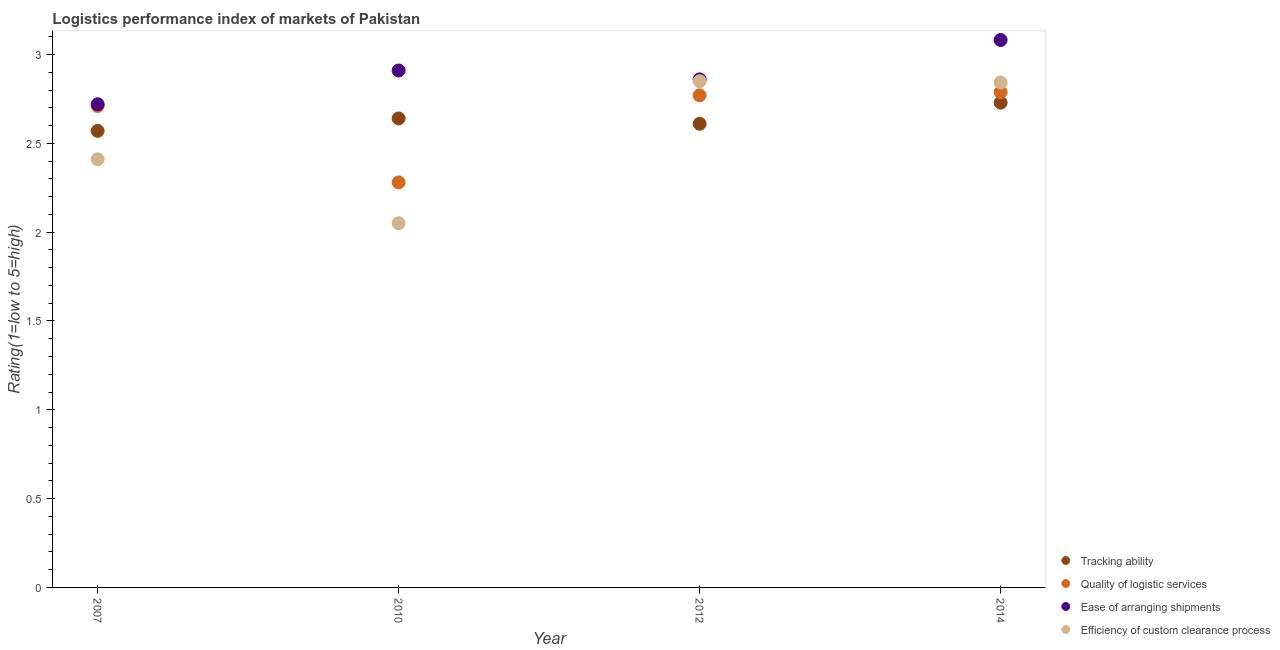How many different coloured dotlines are there?
Keep it short and to the point. 4. Is the number of dotlines equal to the number of legend labels?
Make the answer very short. Yes. What is the lpi rating of efficiency of custom clearance process in 2010?
Your answer should be very brief. 2.05. Across all years, what is the maximum lpi rating of quality of logistic services?
Your answer should be compact. 2.79. Across all years, what is the minimum lpi rating of efficiency of custom clearance process?
Your answer should be very brief. 2.05. In which year was the lpi rating of quality of logistic services minimum?
Offer a terse response. 2010. What is the total lpi rating of tracking ability in the graph?
Ensure brevity in your answer.  10.55. What is the difference between the lpi rating of efficiency of custom clearance process in 2010 and that in 2012?
Give a very brief answer. -0.8. What is the difference between the lpi rating of efficiency of custom clearance process in 2007 and the lpi rating of tracking ability in 2012?
Provide a short and direct response. -0.2. What is the average lpi rating of quality of logistic services per year?
Ensure brevity in your answer.  2.64. In the year 2012, what is the difference between the lpi rating of quality of logistic services and lpi rating of tracking ability?
Give a very brief answer. 0.16. What is the ratio of the lpi rating of quality of logistic services in 2007 to that in 2014?
Provide a short and direct response. 0.97. Is the difference between the lpi rating of tracking ability in 2007 and 2014 greater than the difference between the lpi rating of quality of logistic services in 2007 and 2014?
Give a very brief answer. No. What is the difference between the highest and the second highest lpi rating of ease of arranging shipments?
Offer a very short reply. 0.17. What is the difference between the highest and the lowest lpi rating of quality of logistic services?
Provide a succinct answer. 0.51. Is the sum of the lpi rating of ease of arranging shipments in 2010 and 2014 greater than the maximum lpi rating of tracking ability across all years?
Provide a succinct answer. Yes. Is the lpi rating of efficiency of custom clearance process strictly less than the lpi rating of quality of logistic services over the years?
Offer a very short reply. No. How many dotlines are there?
Provide a short and direct response. 4. How many years are there in the graph?
Offer a terse response. 4. What is the difference between two consecutive major ticks on the Y-axis?
Your answer should be compact. 0.5. Are the values on the major ticks of Y-axis written in scientific E-notation?
Keep it short and to the point. No. Does the graph contain any zero values?
Offer a very short reply. No. Where does the legend appear in the graph?
Give a very brief answer. Bottom right. How many legend labels are there?
Your response must be concise. 4. How are the legend labels stacked?
Your response must be concise. Vertical. What is the title of the graph?
Your answer should be very brief. Logistics performance index of markets of Pakistan. What is the label or title of the Y-axis?
Your response must be concise. Rating(1=low to 5=high). What is the Rating(1=low to 5=high) of Tracking ability in 2007?
Provide a short and direct response. 2.57. What is the Rating(1=low to 5=high) in Quality of logistic services in 2007?
Keep it short and to the point. 2.71. What is the Rating(1=low to 5=high) in Ease of arranging shipments in 2007?
Offer a very short reply. 2.72. What is the Rating(1=low to 5=high) of Efficiency of custom clearance process in 2007?
Your answer should be compact. 2.41. What is the Rating(1=low to 5=high) of Tracking ability in 2010?
Your answer should be compact. 2.64. What is the Rating(1=low to 5=high) in Quality of logistic services in 2010?
Your response must be concise. 2.28. What is the Rating(1=low to 5=high) of Ease of arranging shipments in 2010?
Your response must be concise. 2.91. What is the Rating(1=low to 5=high) in Efficiency of custom clearance process in 2010?
Make the answer very short. 2.05. What is the Rating(1=low to 5=high) of Tracking ability in 2012?
Your answer should be compact. 2.61. What is the Rating(1=low to 5=high) of Quality of logistic services in 2012?
Provide a short and direct response. 2.77. What is the Rating(1=low to 5=high) of Ease of arranging shipments in 2012?
Your answer should be very brief. 2.86. What is the Rating(1=low to 5=high) in Efficiency of custom clearance process in 2012?
Offer a very short reply. 2.85. What is the Rating(1=low to 5=high) in Tracking ability in 2014?
Your answer should be very brief. 2.73. What is the Rating(1=low to 5=high) of Quality of logistic services in 2014?
Your answer should be compact. 2.79. What is the Rating(1=low to 5=high) in Ease of arranging shipments in 2014?
Provide a short and direct response. 3.08. What is the Rating(1=low to 5=high) in Efficiency of custom clearance process in 2014?
Offer a very short reply. 2.84. Across all years, what is the maximum Rating(1=low to 5=high) of Tracking ability?
Offer a terse response. 2.73. Across all years, what is the maximum Rating(1=low to 5=high) of Quality of logistic services?
Provide a short and direct response. 2.79. Across all years, what is the maximum Rating(1=low to 5=high) in Ease of arranging shipments?
Provide a succinct answer. 3.08. Across all years, what is the maximum Rating(1=low to 5=high) in Efficiency of custom clearance process?
Your answer should be very brief. 2.85. Across all years, what is the minimum Rating(1=low to 5=high) in Tracking ability?
Offer a very short reply. 2.57. Across all years, what is the minimum Rating(1=low to 5=high) of Quality of logistic services?
Your answer should be compact. 2.28. Across all years, what is the minimum Rating(1=low to 5=high) of Ease of arranging shipments?
Your answer should be very brief. 2.72. Across all years, what is the minimum Rating(1=low to 5=high) of Efficiency of custom clearance process?
Keep it short and to the point. 2.05. What is the total Rating(1=low to 5=high) in Tracking ability in the graph?
Offer a very short reply. 10.55. What is the total Rating(1=low to 5=high) of Quality of logistic services in the graph?
Your answer should be compact. 10.55. What is the total Rating(1=low to 5=high) of Ease of arranging shipments in the graph?
Your answer should be compact. 11.57. What is the total Rating(1=low to 5=high) in Efficiency of custom clearance process in the graph?
Ensure brevity in your answer.  10.15. What is the difference between the Rating(1=low to 5=high) of Tracking ability in 2007 and that in 2010?
Offer a terse response. -0.07. What is the difference between the Rating(1=low to 5=high) of Quality of logistic services in 2007 and that in 2010?
Keep it short and to the point. 0.43. What is the difference between the Rating(1=low to 5=high) of Ease of arranging shipments in 2007 and that in 2010?
Make the answer very short. -0.19. What is the difference between the Rating(1=low to 5=high) of Efficiency of custom clearance process in 2007 and that in 2010?
Your response must be concise. 0.36. What is the difference between the Rating(1=low to 5=high) of Tracking ability in 2007 and that in 2012?
Your answer should be compact. -0.04. What is the difference between the Rating(1=low to 5=high) in Quality of logistic services in 2007 and that in 2012?
Your response must be concise. -0.06. What is the difference between the Rating(1=low to 5=high) of Ease of arranging shipments in 2007 and that in 2012?
Your answer should be compact. -0.14. What is the difference between the Rating(1=low to 5=high) of Efficiency of custom clearance process in 2007 and that in 2012?
Offer a terse response. -0.44. What is the difference between the Rating(1=low to 5=high) of Tracking ability in 2007 and that in 2014?
Offer a terse response. -0.16. What is the difference between the Rating(1=low to 5=high) in Quality of logistic services in 2007 and that in 2014?
Your response must be concise. -0.08. What is the difference between the Rating(1=low to 5=high) of Ease of arranging shipments in 2007 and that in 2014?
Provide a short and direct response. -0.36. What is the difference between the Rating(1=low to 5=high) in Efficiency of custom clearance process in 2007 and that in 2014?
Make the answer very short. -0.43. What is the difference between the Rating(1=low to 5=high) of Tracking ability in 2010 and that in 2012?
Make the answer very short. 0.03. What is the difference between the Rating(1=low to 5=high) in Quality of logistic services in 2010 and that in 2012?
Give a very brief answer. -0.49. What is the difference between the Rating(1=low to 5=high) in Ease of arranging shipments in 2010 and that in 2012?
Ensure brevity in your answer.  0.05. What is the difference between the Rating(1=low to 5=high) in Tracking ability in 2010 and that in 2014?
Provide a succinct answer. -0.09. What is the difference between the Rating(1=low to 5=high) of Quality of logistic services in 2010 and that in 2014?
Provide a short and direct response. -0.51. What is the difference between the Rating(1=low to 5=high) of Ease of arranging shipments in 2010 and that in 2014?
Offer a very short reply. -0.17. What is the difference between the Rating(1=low to 5=high) in Efficiency of custom clearance process in 2010 and that in 2014?
Ensure brevity in your answer.  -0.79. What is the difference between the Rating(1=low to 5=high) of Tracking ability in 2012 and that in 2014?
Give a very brief answer. -0.12. What is the difference between the Rating(1=low to 5=high) in Quality of logistic services in 2012 and that in 2014?
Ensure brevity in your answer.  -0.02. What is the difference between the Rating(1=low to 5=high) in Ease of arranging shipments in 2012 and that in 2014?
Provide a succinct answer. -0.22. What is the difference between the Rating(1=low to 5=high) of Efficiency of custom clearance process in 2012 and that in 2014?
Provide a short and direct response. 0.01. What is the difference between the Rating(1=low to 5=high) in Tracking ability in 2007 and the Rating(1=low to 5=high) in Quality of logistic services in 2010?
Provide a short and direct response. 0.29. What is the difference between the Rating(1=low to 5=high) of Tracking ability in 2007 and the Rating(1=low to 5=high) of Ease of arranging shipments in 2010?
Provide a short and direct response. -0.34. What is the difference between the Rating(1=low to 5=high) of Tracking ability in 2007 and the Rating(1=low to 5=high) of Efficiency of custom clearance process in 2010?
Your response must be concise. 0.52. What is the difference between the Rating(1=low to 5=high) of Quality of logistic services in 2007 and the Rating(1=low to 5=high) of Ease of arranging shipments in 2010?
Ensure brevity in your answer.  -0.2. What is the difference between the Rating(1=low to 5=high) of Quality of logistic services in 2007 and the Rating(1=low to 5=high) of Efficiency of custom clearance process in 2010?
Make the answer very short. 0.66. What is the difference between the Rating(1=low to 5=high) in Ease of arranging shipments in 2007 and the Rating(1=low to 5=high) in Efficiency of custom clearance process in 2010?
Keep it short and to the point. 0.67. What is the difference between the Rating(1=low to 5=high) in Tracking ability in 2007 and the Rating(1=low to 5=high) in Ease of arranging shipments in 2012?
Keep it short and to the point. -0.29. What is the difference between the Rating(1=low to 5=high) of Tracking ability in 2007 and the Rating(1=low to 5=high) of Efficiency of custom clearance process in 2012?
Give a very brief answer. -0.28. What is the difference between the Rating(1=low to 5=high) in Quality of logistic services in 2007 and the Rating(1=low to 5=high) in Ease of arranging shipments in 2012?
Offer a very short reply. -0.15. What is the difference between the Rating(1=low to 5=high) in Quality of logistic services in 2007 and the Rating(1=low to 5=high) in Efficiency of custom clearance process in 2012?
Give a very brief answer. -0.14. What is the difference between the Rating(1=low to 5=high) in Ease of arranging shipments in 2007 and the Rating(1=low to 5=high) in Efficiency of custom clearance process in 2012?
Offer a very short reply. -0.13. What is the difference between the Rating(1=low to 5=high) in Tracking ability in 2007 and the Rating(1=low to 5=high) in Quality of logistic services in 2014?
Your response must be concise. -0.22. What is the difference between the Rating(1=low to 5=high) of Tracking ability in 2007 and the Rating(1=low to 5=high) of Ease of arranging shipments in 2014?
Keep it short and to the point. -0.51. What is the difference between the Rating(1=low to 5=high) in Tracking ability in 2007 and the Rating(1=low to 5=high) in Efficiency of custom clearance process in 2014?
Ensure brevity in your answer.  -0.27. What is the difference between the Rating(1=low to 5=high) of Quality of logistic services in 2007 and the Rating(1=low to 5=high) of Ease of arranging shipments in 2014?
Offer a terse response. -0.37. What is the difference between the Rating(1=low to 5=high) of Quality of logistic services in 2007 and the Rating(1=low to 5=high) of Efficiency of custom clearance process in 2014?
Keep it short and to the point. -0.13. What is the difference between the Rating(1=low to 5=high) of Ease of arranging shipments in 2007 and the Rating(1=low to 5=high) of Efficiency of custom clearance process in 2014?
Offer a terse response. -0.12. What is the difference between the Rating(1=low to 5=high) in Tracking ability in 2010 and the Rating(1=low to 5=high) in Quality of logistic services in 2012?
Offer a very short reply. -0.13. What is the difference between the Rating(1=low to 5=high) in Tracking ability in 2010 and the Rating(1=low to 5=high) in Ease of arranging shipments in 2012?
Your response must be concise. -0.22. What is the difference between the Rating(1=low to 5=high) in Tracking ability in 2010 and the Rating(1=low to 5=high) in Efficiency of custom clearance process in 2012?
Make the answer very short. -0.21. What is the difference between the Rating(1=low to 5=high) in Quality of logistic services in 2010 and the Rating(1=low to 5=high) in Ease of arranging shipments in 2012?
Keep it short and to the point. -0.58. What is the difference between the Rating(1=low to 5=high) of Quality of logistic services in 2010 and the Rating(1=low to 5=high) of Efficiency of custom clearance process in 2012?
Make the answer very short. -0.57. What is the difference between the Rating(1=low to 5=high) in Tracking ability in 2010 and the Rating(1=low to 5=high) in Quality of logistic services in 2014?
Make the answer very short. -0.15. What is the difference between the Rating(1=low to 5=high) in Tracking ability in 2010 and the Rating(1=low to 5=high) in Ease of arranging shipments in 2014?
Offer a terse response. -0.44. What is the difference between the Rating(1=low to 5=high) of Tracking ability in 2010 and the Rating(1=low to 5=high) of Efficiency of custom clearance process in 2014?
Your answer should be very brief. -0.2. What is the difference between the Rating(1=low to 5=high) of Quality of logistic services in 2010 and the Rating(1=low to 5=high) of Ease of arranging shipments in 2014?
Your answer should be compact. -0.8. What is the difference between the Rating(1=low to 5=high) in Quality of logistic services in 2010 and the Rating(1=low to 5=high) in Efficiency of custom clearance process in 2014?
Ensure brevity in your answer.  -0.56. What is the difference between the Rating(1=low to 5=high) in Ease of arranging shipments in 2010 and the Rating(1=low to 5=high) in Efficiency of custom clearance process in 2014?
Your answer should be very brief. 0.07. What is the difference between the Rating(1=low to 5=high) in Tracking ability in 2012 and the Rating(1=low to 5=high) in Quality of logistic services in 2014?
Offer a terse response. -0.18. What is the difference between the Rating(1=low to 5=high) in Tracking ability in 2012 and the Rating(1=low to 5=high) in Ease of arranging shipments in 2014?
Make the answer very short. -0.47. What is the difference between the Rating(1=low to 5=high) in Tracking ability in 2012 and the Rating(1=low to 5=high) in Efficiency of custom clearance process in 2014?
Make the answer very short. -0.23. What is the difference between the Rating(1=low to 5=high) in Quality of logistic services in 2012 and the Rating(1=low to 5=high) in Ease of arranging shipments in 2014?
Your answer should be very brief. -0.31. What is the difference between the Rating(1=low to 5=high) of Quality of logistic services in 2012 and the Rating(1=low to 5=high) of Efficiency of custom clearance process in 2014?
Provide a succinct answer. -0.07. What is the difference between the Rating(1=low to 5=high) in Ease of arranging shipments in 2012 and the Rating(1=low to 5=high) in Efficiency of custom clearance process in 2014?
Provide a succinct answer. 0.02. What is the average Rating(1=low to 5=high) of Tracking ability per year?
Give a very brief answer. 2.64. What is the average Rating(1=low to 5=high) in Quality of logistic services per year?
Give a very brief answer. 2.64. What is the average Rating(1=low to 5=high) of Ease of arranging shipments per year?
Your response must be concise. 2.89. What is the average Rating(1=low to 5=high) in Efficiency of custom clearance process per year?
Offer a very short reply. 2.54. In the year 2007, what is the difference between the Rating(1=low to 5=high) of Tracking ability and Rating(1=low to 5=high) of Quality of logistic services?
Your answer should be very brief. -0.14. In the year 2007, what is the difference between the Rating(1=low to 5=high) of Tracking ability and Rating(1=low to 5=high) of Ease of arranging shipments?
Give a very brief answer. -0.15. In the year 2007, what is the difference between the Rating(1=low to 5=high) of Tracking ability and Rating(1=low to 5=high) of Efficiency of custom clearance process?
Give a very brief answer. 0.16. In the year 2007, what is the difference between the Rating(1=low to 5=high) of Quality of logistic services and Rating(1=low to 5=high) of Ease of arranging shipments?
Ensure brevity in your answer.  -0.01. In the year 2007, what is the difference between the Rating(1=low to 5=high) of Quality of logistic services and Rating(1=low to 5=high) of Efficiency of custom clearance process?
Offer a very short reply. 0.3. In the year 2007, what is the difference between the Rating(1=low to 5=high) in Ease of arranging shipments and Rating(1=low to 5=high) in Efficiency of custom clearance process?
Give a very brief answer. 0.31. In the year 2010, what is the difference between the Rating(1=low to 5=high) of Tracking ability and Rating(1=low to 5=high) of Quality of logistic services?
Offer a very short reply. 0.36. In the year 2010, what is the difference between the Rating(1=low to 5=high) in Tracking ability and Rating(1=low to 5=high) in Ease of arranging shipments?
Your answer should be very brief. -0.27. In the year 2010, what is the difference between the Rating(1=low to 5=high) of Tracking ability and Rating(1=low to 5=high) of Efficiency of custom clearance process?
Offer a terse response. 0.59. In the year 2010, what is the difference between the Rating(1=low to 5=high) of Quality of logistic services and Rating(1=low to 5=high) of Ease of arranging shipments?
Your answer should be compact. -0.63. In the year 2010, what is the difference between the Rating(1=low to 5=high) of Quality of logistic services and Rating(1=low to 5=high) of Efficiency of custom clearance process?
Provide a short and direct response. 0.23. In the year 2010, what is the difference between the Rating(1=low to 5=high) in Ease of arranging shipments and Rating(1=low to 5=high) in Efficiency of custom clearance process?
Make the answer very short. 0.86. In the year 2012, what is the difference between the Rating(1=low to 5=high) in Tracking ability and Rating(1=low to 5=high) in Quality of logistic services?
Your answer should be compact. -0.16. In the year 2012, what is the difference between the Rating(1=low to 5=high) in Tracking ability and Rating(1=low to 5=high) in Efficiency of custom clearance process?
Give a very brief answer. -0.24. In the year 2012, what is the difference between the Rating(1=low to 5=high) in Quality of logistic services and Rating(1=low to 5=high) in Ease of arranging shipments?
Offer a very short reply. -0.09. In the year 2012, what is the difference between the Rating(1=low to 5=high) in Quality of logistic services and Rating(1=low to 5=high) in Efficiency of custom clearance process?
Make the answer very short. -0.08. In the year 2012, what is the difference between the Rating(1=low to 5=high) in Ease of arranging shipments and Rating(1=low to 5=high) in Efficiency of custom clearance process?
Offer a very short reply. 0.01. In the year 2014, what is the difference between the Rating(1=low to 5=high) of Tracking ability and Rating(1=low to 5=high) of Quality of logistic services?
Give a very brief answer. -0.06. In the year 2014, what is the difference between the Rating(1=low to 5=high) in Tracking ability and Rating(1=low to 5=high) in Ease of arranging shipments?
Offer a very short reply. -0.35. In the year 2014, what is the difference between the Rating(1=low to 5=high) of Tracking ability and Rating(1=low to 5=high) of Efficiency of custom clearance process?
Make the answer very short. -0.11. In the year 2014, what is the difference between the Rating(1=low to 5=high) of Quality of logistic services and Rating(1=low to 5=high) of Ease of arranging shipments?
Make the answer very short. -0.29. In the year 2014, what is the difference between the Rating(1=low to 5=high) in Quality of logistic services and Rating(1=low to 5=high) in Efficiency of custom clearance process?
Your answer should be compact. -0.05. In the year 2014, what is the difference between the Rating(1=low to 5=high) in Ease of arranging shipments and Rating(1=low to 5=high) in Efficiency of custom clearance process?
Keep it short and to the point. 0.24. What is the ratio of the Rating(1=low to 5=high) in Tracking ability in 2007 to that in 2010?
Provide a succinct answer. 0.97. What is the ratio of the Rating(1=low to 5=high) of Quality of logistic services in 2007 to that in 2010?
Ensure brevity in your answer.  1.19. What is the ratio of the Rating(1=low to 5=high) in Ease of arranging shipments in 2007 to that in 2010?
Ensure brevity in your answer.  0.93. What is the ratio of the Rating(1=low to 5=high) in Efficiency of custom clearance process in 2007 to that in 2010?
Ensure brevity in your answer.  1.18. What is the ratio of the Rating(1=low to 5=high) of Tracking ability in 2007 to that in 2012?
Keep it short and to the point. 0.98. What is the ratio of the Rating(1=low to 5=high) of Quality of logistic services in 2007 to that in 2012?
Ensure brevity in your answer.  0.98. What is the ratio of the Rating(1=low to 5=high) in Ease of arranging shipments in 2007 to that in 2012?
Make the answer very short. 0.95. What is the ratio of the Rating(1=low to 5=high) in Efficiency of custom clearance process in 2007 to that in 2012?
Provide a succinct answer. 0.85. What is the ratio of the Rating(1=low to 5=high) in Tracking ability in 2007 to that in 2014?
Your answer should be very brief. 0.94. What is the ratio of the Rating(1=low to 5=high) in Quality of logistic services in 2007 to that in 2014?
Offer a very short reply. 0.97. What is the ratio of the Rating(1=low to 5=high) of Ease of arranging shipments in 2007 to that in 2014?
Offer a terse response. 0.88. What is the ratio of the Rating(1=low to 5=high) in Efficiency of custom clearance process in 2007 to that in 2014?
Give a very brief answer. 0.85. What is the ratio of the Rating(1=low to 5=high) of Tracking ability in 2010 to that in 2012?
Your response must be concise. 1.01. What is the ratio of the Rating(1=low to 5=high) of Quality of logistic services in 2010 to that in 2012?
Provide a succinct answer. 0.82. What is the ratio of the Rating(1=low to 5=high) in Ease of arranging shipments in 2010 to that in 2012?
Provide a succinct answer. 1.02. What is the ratio of the Rating(1=low to 5=high) of Efficiency of custom clearance process in 2010 to that in 2012?
Your response must be concise. 0.72. What is the ratio of the Rating(1=low to 5=high) of Tracking ability in 2010 to that in 2014?
Make the answer very short. 0.97. What is the ratio of the Rating(1=low to 5=high) of Quality of logistic services in 2010 to that in 2014?
Make the answer very short. 0.82. What is the ratio of the Rating(1=low to 5=high) of Ease of arranging shipments in 2010 to that in 2014?
Offer a terse response. 0.94. What is the ratio of the Rating(1=low to 5=high) of Efficiency of custom clearance process in 2010 to that in 2014?
Offer a terse response. 0.72. What is the ratio of the Rating(1=low to 5=high) of Tracking ability in 2012 to that in 2014?
Make the answer very short. 0.96. What is the ratio of the Rating(1=low to 5=high) in Quality of logistic services in 2012 to that in 2014?
Ensure brevity in your answer.  0.99. What is the ratio of the Rating(1=low to 5=high) in Ease of arranging shipments in 2012 to that in 2014?
Provide a short and direct response. 0.93. What is the difference between the highest and the second highest Rating(1=low to 5=high) in Tracking ability?
Your response must be concise. 0.09. What is the difference between the highest and the second highest Rating(1=low to 5=high) of Quality of logistic services?
Keep it short and to the point. 0.02. What is the difference between the highest and the second highest Rating(1=low to 5=high) of Ease of arranging shipments?
Keep it short and to the point. 0.17. What is the difference between the highest and the second highest Rating(1=low to 5=high) in Efficiency of custom clearance process?
Keep it short and to the point. 0.01. What is the difference between the highest and the lowest Rating(1=low to 5=high) of Tracking ability?
Make the answer very short. 0.16. What is the difference between the highest and the lowest Rating(1=low to 5=high) in Quality of logistic services?
Your response must be concise. 0.51. What is the difference between the highest and the lowest Rating(1=low to 5=high) of Ease of arranging shipments?
Your response must be concise. 0.36. What is the difference between the highest and the lowest Rating(1=low to 5=high) in Efficiency of custom clearance process?
Provide a succinct answer. 0.8. 